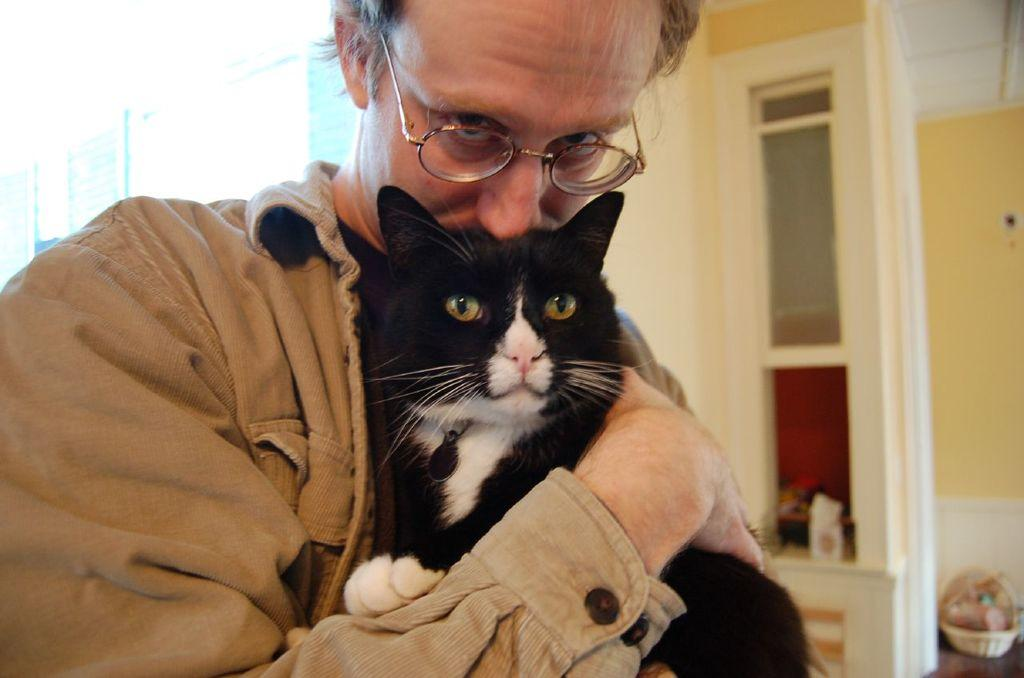What is the person in the image holding? The person is holding a cat in the image. What can be seen in the background of the image? There are walls, a cupboard, and a basket visible in the background of the image. Can you describe any other objects or features in the background? There are other things visible in the background of the image, but their specific details are not mentioned in the provided facts. What type of skin is visible on the cat in the image? The type of skin on the cat is not visible in the image, as the focus is on the person holding the cat. --- Facts: 1. There is a person sitting on a chair in the image. 2. The person is holding a book. 3. There is a table in front of the person. 4. There is a lamp on the table. 5. There is a window in the background of the image. Absurd Topics: dance, ocean, bird Conversation: What is the person in the image doing? The person is sitting on a chair in the image. What is the person holding? The person is holding a book. What is on the table in front of the person? There is a lamp on the table. What can be seen in the background of the image? There is a window in the background of the image. Reasoning: Let's think step by step in order to produce the conversation. We start by identifying the main subject in the image, which is the person sitting on a chair. Then, we expand the conversation to include the book the person is holding, the table in front of them, and the lamp on the table. Finally, we mention the window visible in the background of the image. Each question is designed to elicit a specific detail about the image that is known from the provided facts. Absurd Question/Answer: Can you see any ocean waves in the image? There is no mention of an ocean or waves in the image, as the focus is on the person sitting on a chair, holding a book, and the objects on the table and in the background. 